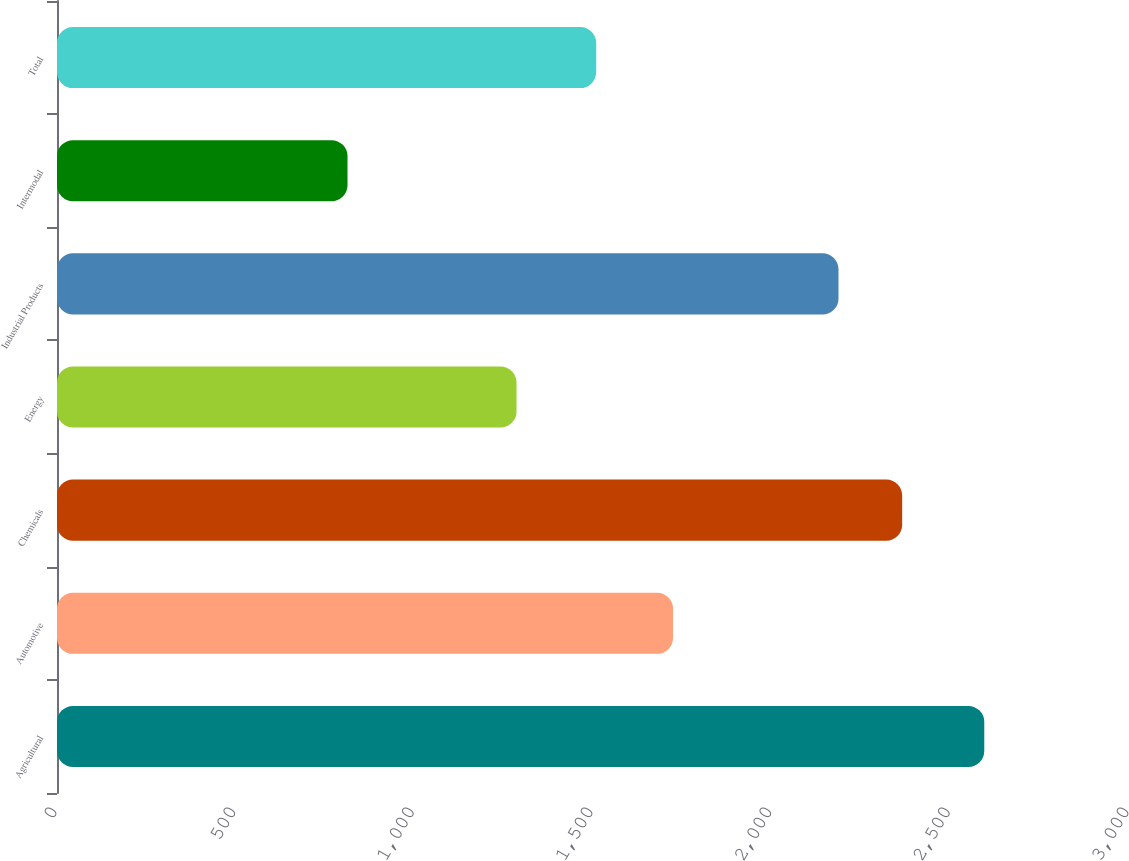Convert chart. <chart><loc_0><loc_0><loc_500><loc_500><bar_chart><fcel>Agricultural<fcel>Automotive<fcel>Chemicals<fcel>Energy<fcel>Industrial Products<fcel>Intermodal<fcel>Total<nl><fcel>2595<fcel>1724<fcel>2365.2<fcel>1286<fcel>2187<fcel>813<fcel>1509<nl></chart> 